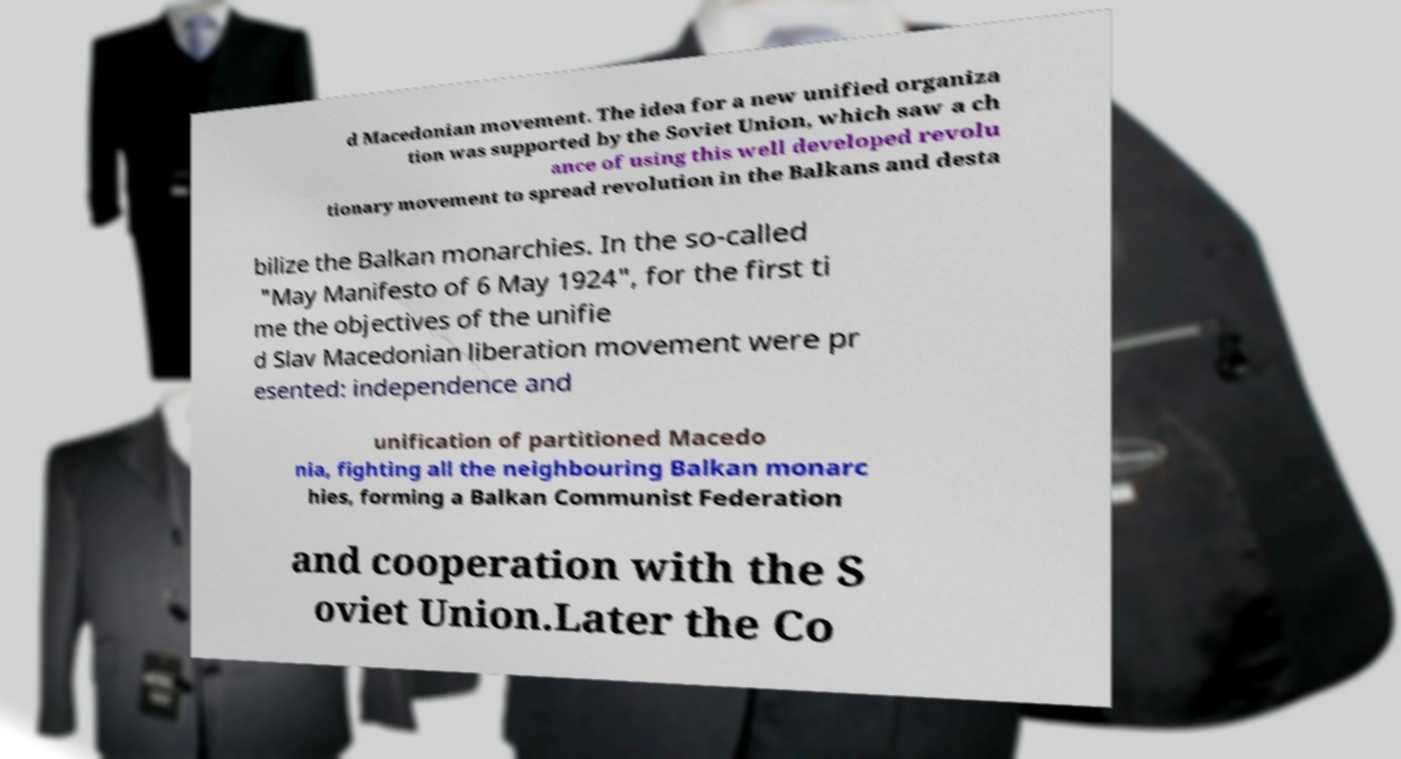For documentation purposes, I need the text within this image transcribed. Could you provide that? d Macedonian movement. The idea for a new unified organiza tion was supported by the Soviet Union, which saw a ch ance of using this well developed revolu tionary movement to spread revolution in the Balkans and desta bilize the Balkan monarchies. In the so-called "May Manifesto of 6 May 1924", for the first ti me the objectives of the unifie d Slav Macedonian liberation movement were pr esented: independence and unification of partitioned Macedo nia, fighting all the neighbouring Balkan monarc hies, forming a Balkan Communist Federation and cooperation with the S oviet Union.Later the Co 